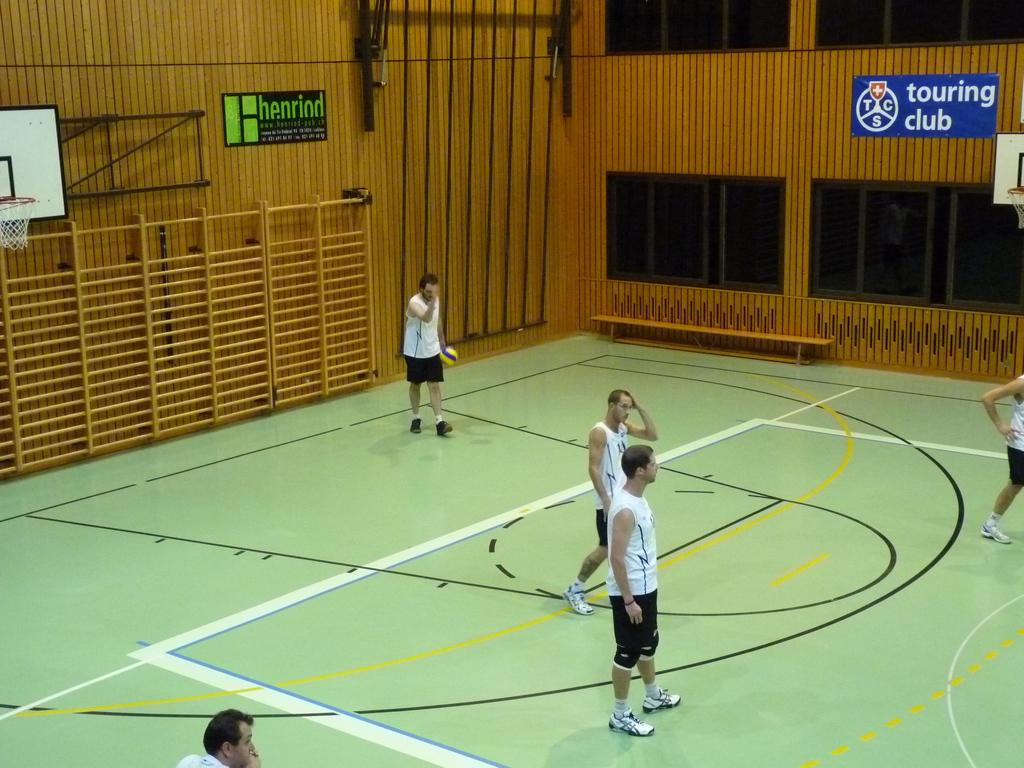<image>
Describe the image concisely. A blue sign for the touring club hangs on the wall in a basketball gym. 